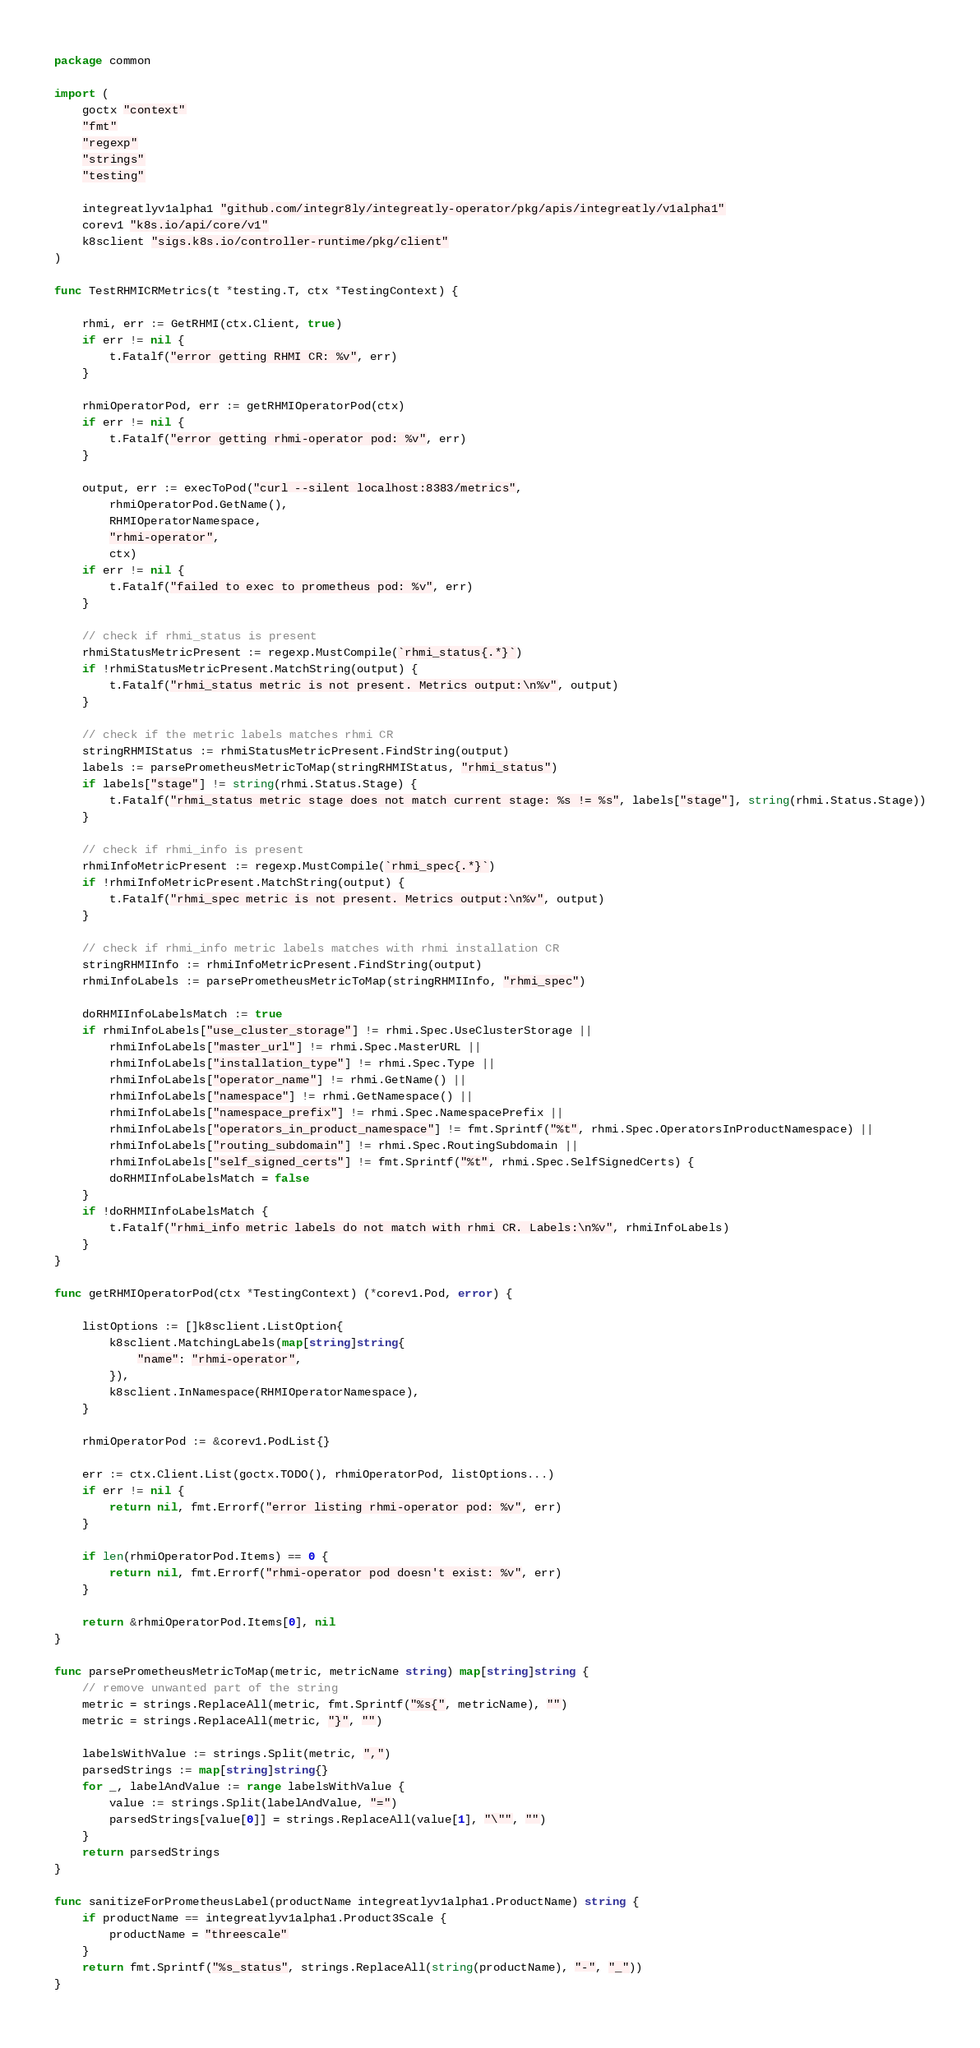Convert code to text. <code><loc_0><loc_0><loc_500><loc_500><_Go_>package common

import (
	goctx "context"
	"fmt"
	"regexp"
	"strings"
	"testing"

	integreatlyv1alpha1 "github.com/integr8ly/integreatly-operator/pkg/apis/integreatly/v1alpha1"
	corev1 "k8s.io/api/core/v1"
	k8sclient "sigs.k8s.io/controller-runtime/pkg/client"
)

func TestRHMICRMetrics(t *testing.T, ctx *TestingContext) {

	rhmi, err := GetRHMI(ctx.Client, true)
	if err != nil {
		t.Fatalf("error getting RHMI CR: %v", err)
	}

	rhmiOperatorPod, err := getRHMIOperatorPod(ctx)
	if err != nil {
		t.Fatalf("error getting rhmi-operator pod: %v", err)
	}

	output, err := execToPod("curl --silent localhost:8383/metrics",
		rhmiOperatorPod.GetName(),
		RHMIOperatorNamespace,
		"rhmi-operator",
		ctx)
	if err != nil {
		t.Fatalf("failed to exec to prometheus pod: %v", err)
	}

	// check if rhmi_status is present
	rhmiStatusMetricPresent := regexp.MustCompile(`rhmi_status{.*}`)
	if !rhmiStatusMetricPresent.MatchString(output) {
		t.Fatalf("rhmi_status metric is not present. Metrics output:\n%v", output)
	}

	// check if the metric labels matches rhmi CR
	stringRHMIStatus := rhmiStatusMetricPresent.FindString(output)
	labels := parsePrometheusMetricToMap(stringRHMIStatus, "rhmi_status")
	if labels["stage"] != string(rhmi.Status.Stage) {
		t.Fatalf("rhmi_status metric stage does not match current stage: %s != %s", labels["stage"], string(rhmi.Status.Stage))
	}

	// check if rhmi_info is present
	rhmiInfoMetricPresent := regexp.MustCompile(`rhmi_spec{.*}`)
	if !rhmiInfoMetricPresent.MatchString(output) {
		t.Fatalf("rhmi_spec metric is not present. Metrics output:\n%v", output)
	}

	// check if rhmi_info metric labels matches with rhmi installation CR
	stringRHMIInfo := rhmiInfoMetricPresent.FindString(output)
	rhmiInfoLabels := parsePrometheusMetricToMap(stringRHMIInfo, "rhmi_spec")

	doRHMIInfoLabelsMatch := true
	if rhmiInfoLabels["use_cluster_storage"] != rhmi.Spec.UseClusterStorage ||
		rhmiInfoLabels["master_url"] != rhmi.Spec.MasterURL ||
		rhmiInfoLabels["installation_type"] != rhmi.Spec.Type ||
		rhmiInfoLabels["operator_name"] != rhmi.GetName() ||
		rhmiInfoLabels["namespace"] != rhmi.GetNamespace() ||
		rhmiInfoLabels["namespace_prefix"] != rhmi.Spec.NamespacePrefix ||
		rhmiInfoLabels["operators_in_product_namespace"] != fmt.Sprintf("%t", rhmi.Spec.OperatorsInProductNamespace) ||
		rhmiInfoLabels["routing_subdomain"] != rhmi.Spec.RoutingSubdomain ||
		rhmiInfoLabels["self_signed_certs"] != fmt.Sprintf("%t", rhmi.Spec.SelfSignedCerts) {
		doRHMIInfoLabelsMatch = false
	}
	if !doRHMIInfoLabelsMatch {
		t.Fatalf("rhmi_info metric labels do not match with rhmi CR. Labels:\n%v", rhmiInfoLabels)
	}
}

func getRHMIOperatorPod(ctx *TestingContext) (*corev1.Pod, error) {

	listOptions := []k8sclient.ListOption{
		k8sclient.MatchingLabels(map[string]string{
			"name": "rhmi-operator",
		}),
		k8sclient.InNamespace(RHMIOperatorNamespace),
	}

	rhmiOperatorPod := &corev1.PodList{}

	err := ctx.Client.List(goctx.TODO(), rhmiOperatorPod, listOptions...)
	if err != nil {
		return nil, fmt.Errorf("error listing rhmi-operator pod: %v", err)
	}

	if len(rhmiOperatorPod.Items) == 0 {
		return nil, fmt.Errorf("rhmi-operator pod doesn't exist: %v", err)
	}

	return &rhmiOperatorPod.Items[0], nil
}

func parsePrometheusMetricToMap(metric, metricName string) map[string]string {
	// remove unwanted part of the string
	metric = strings.ReplaceAll(metric, fmt.Sprintf("%s{", metricName), "")
	metric = strings.ReplaceAll(metric, "}", "")

	labelsWithValue := strings.Split(metric, ",")
	parsedStrings := map[string]string{}
	for _, labelAndValue := range labelsWithValue {
		value := strings.Split(labelAndValue, "=")
		parsedStrings[value[0]] = strings.ReplaceAll(value[1], "\"", "")
	}
	return parsedStrings
}

func sanitizeForPrometheusLabel(productName integreatlyv1alpha1.ProductName) string {
	if productName == integreatlyv1alpha1.Product3Scale {
		productName = "threescale"
	}
	return fmt.Sprintf("%s_status", strings.ReplaceAll(string(productName), "-", "_"))
}
</code> 